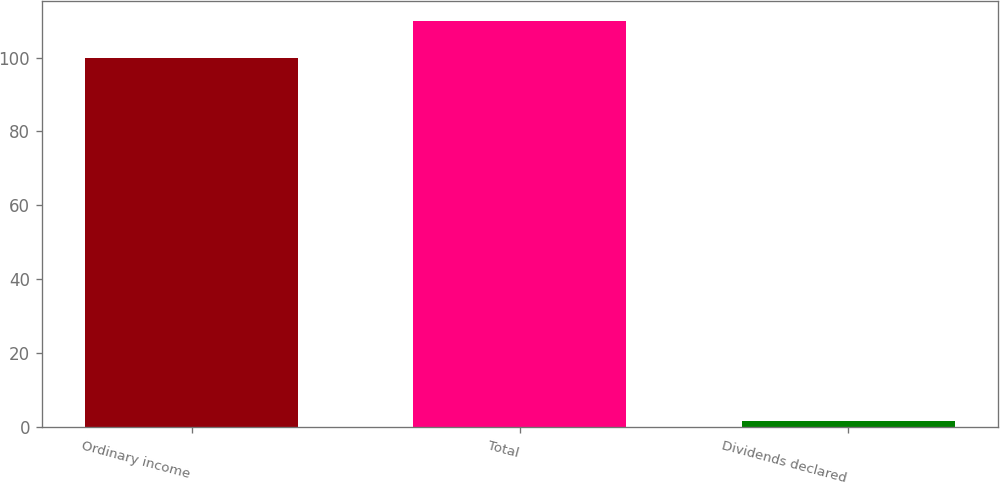Convert chart to OTSL. <chart><loc_0><loc_0><loc_500><loc_500><bar_chart><fcel>Ordinary income<fcel>Total<fcel>Dividends declared<nl><fcel>100<fcel>109.84<fcel>1.61<nl></chart> 